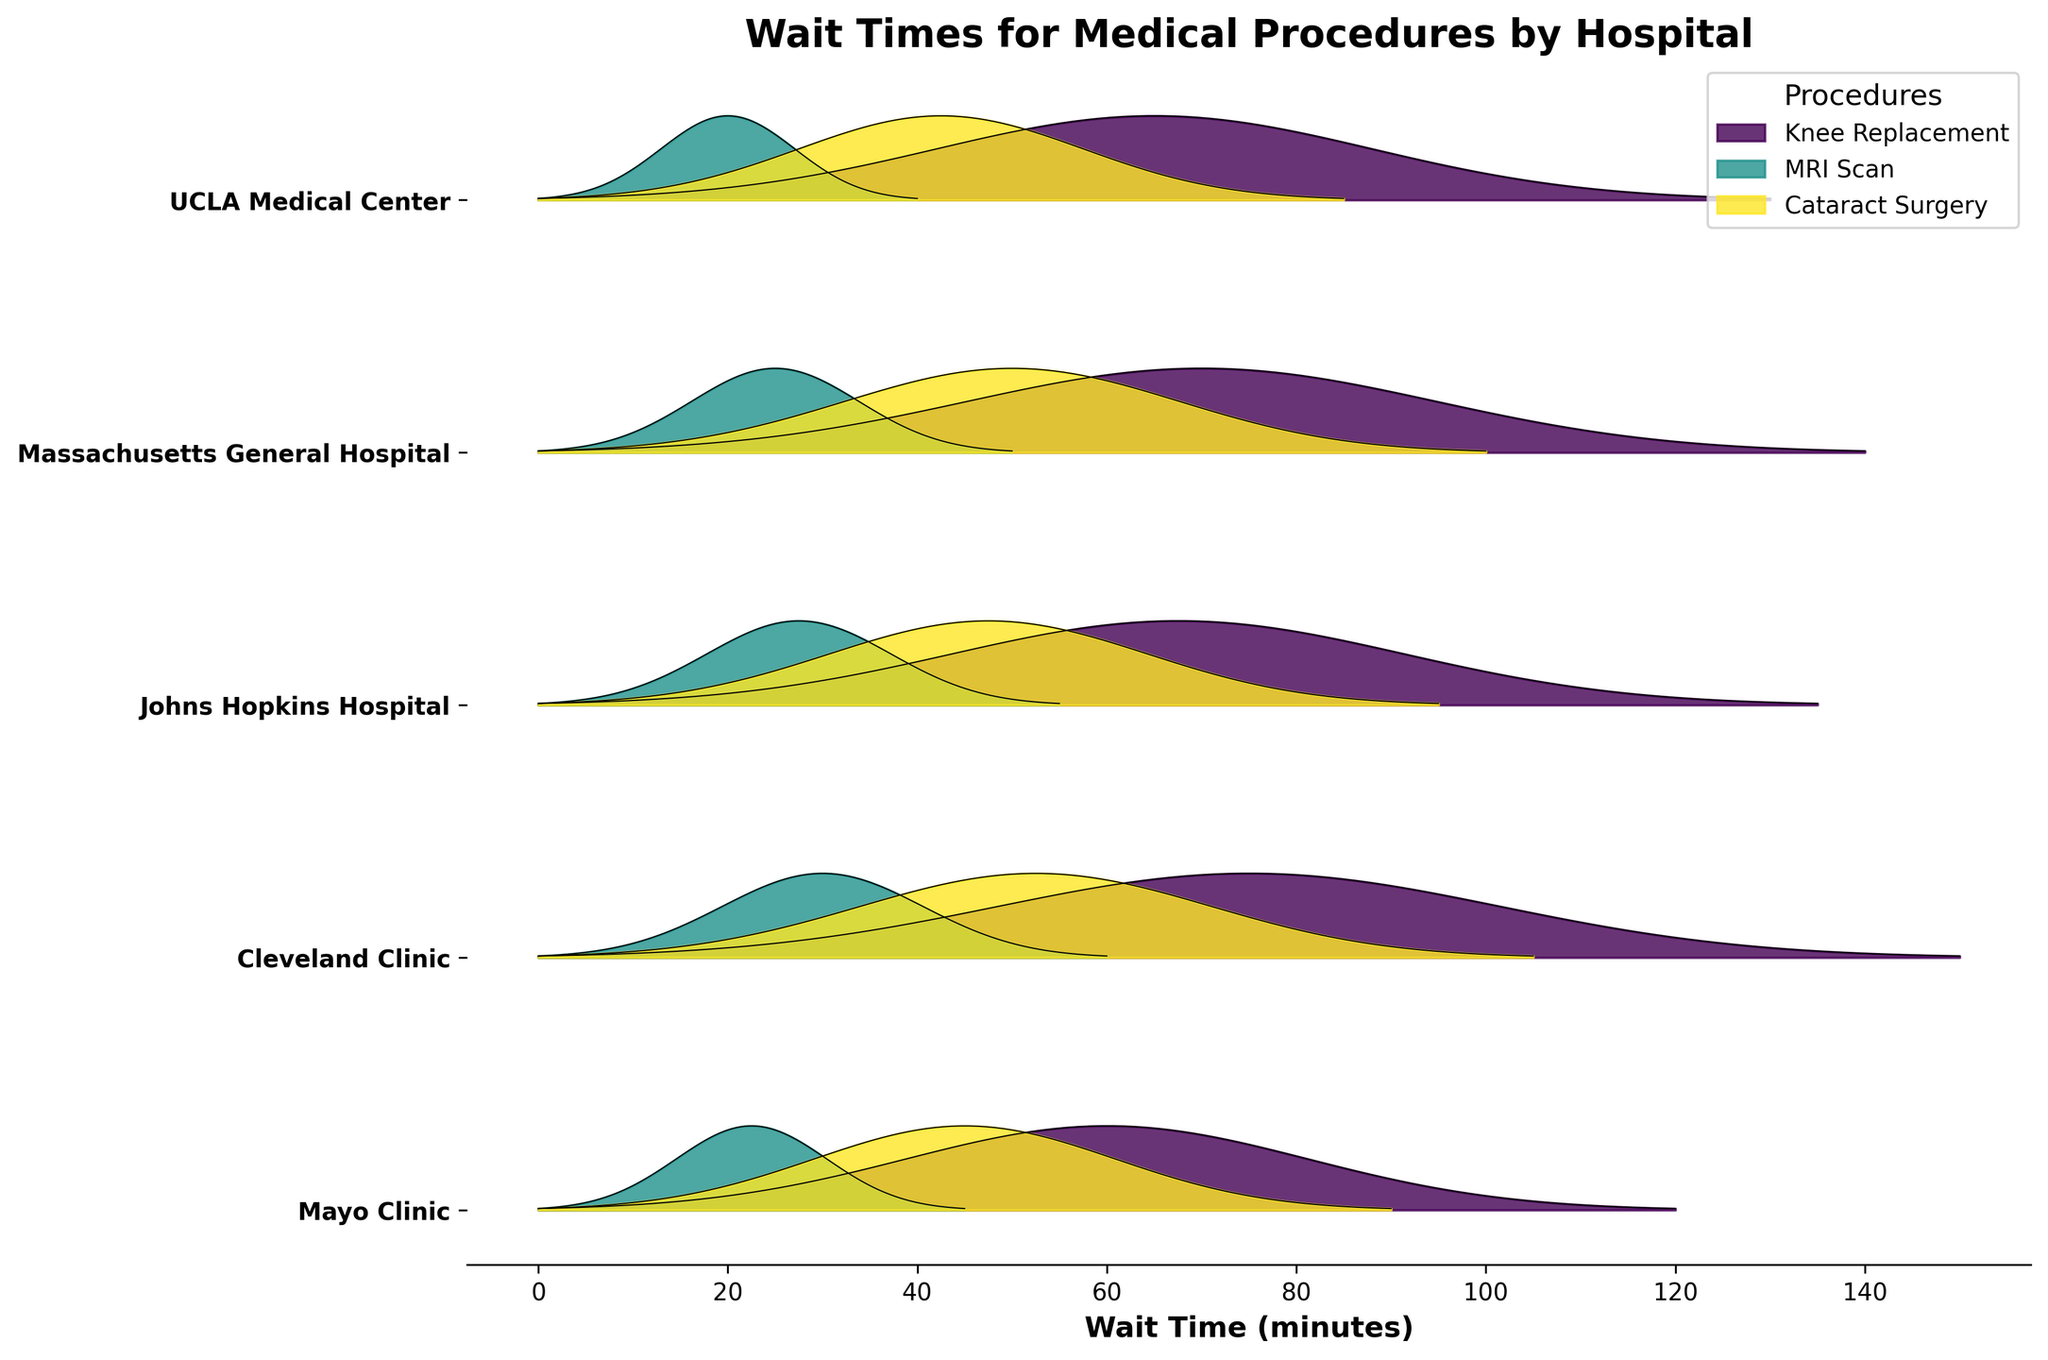Which hospital has the longest wait time for a Knee Replacement procedure? To find this, look at the ridgeline representing the Knee Replacement procedure for each hospital, and identify the one with the longest span on the x-axis.
Answer: Cleveland Clinic What are the different medical procedures shown in this plot? Identify the labels in the legend, which represent different procedures.
Answer: Knee Replacement, MRI Scan, Cataract Surgery Which medical procedure generally appears to have the shortest wait times across hospitals? Observe the ridgelines for each procedure across all hospitals; the one with the shortest x-axis spans overall represents the shortest wait times.
Answer: MRI Scan Compare the wait times for Cataract Surgery between Mayo Clinic and UCLA Medical Center. Which one is shorter? Find the ridgeline for Cataract Surgery at Mayo Clinic and UCLA Medical Center, then compare their spans on the x-axis.
Answer: UCLA Medical Center On average, do larger hospitals (with higher patient volume) have longer or shorter wait times for an MRI Scan? Look at the general peak positions for MRI Scan ridgelines for hospitals that are known to be large and high volume versus smaller ones and observe the trends.
Answer: Shorter What is the title of the plot? The title is shown at the top of the plot in bold letters.
Answer: Wait Times for Medical Procedures by Hospital Which hospital has the most balanced wait times across all three procedures? Assess the spans of ridgelines for each procedure within a single hospital and compare their consistency in lengths.
Answer: UCLA Medical Center What is the range of wait times for Knee Replacement across all hospitals? Identify the shortest and longest x-axis values for ridgelines representing Knee Replacement across all hospitals.
Answer: 120 to 150 minutes Which procedure appears to have the most variability in wait times across different hospitals? Compare the lengths of ridgelines across hospitals for each procedure and identify which one has the greatest variance.
Answer: Knee Replacement Is there a general trend where wait times increase or decrease among the hospitals listed from left to right? Observe the positions of the peaks on the x-axis for ridgelines corresponding to each procedure across hospitals arranged from left to right.
Answer: No clear trend 